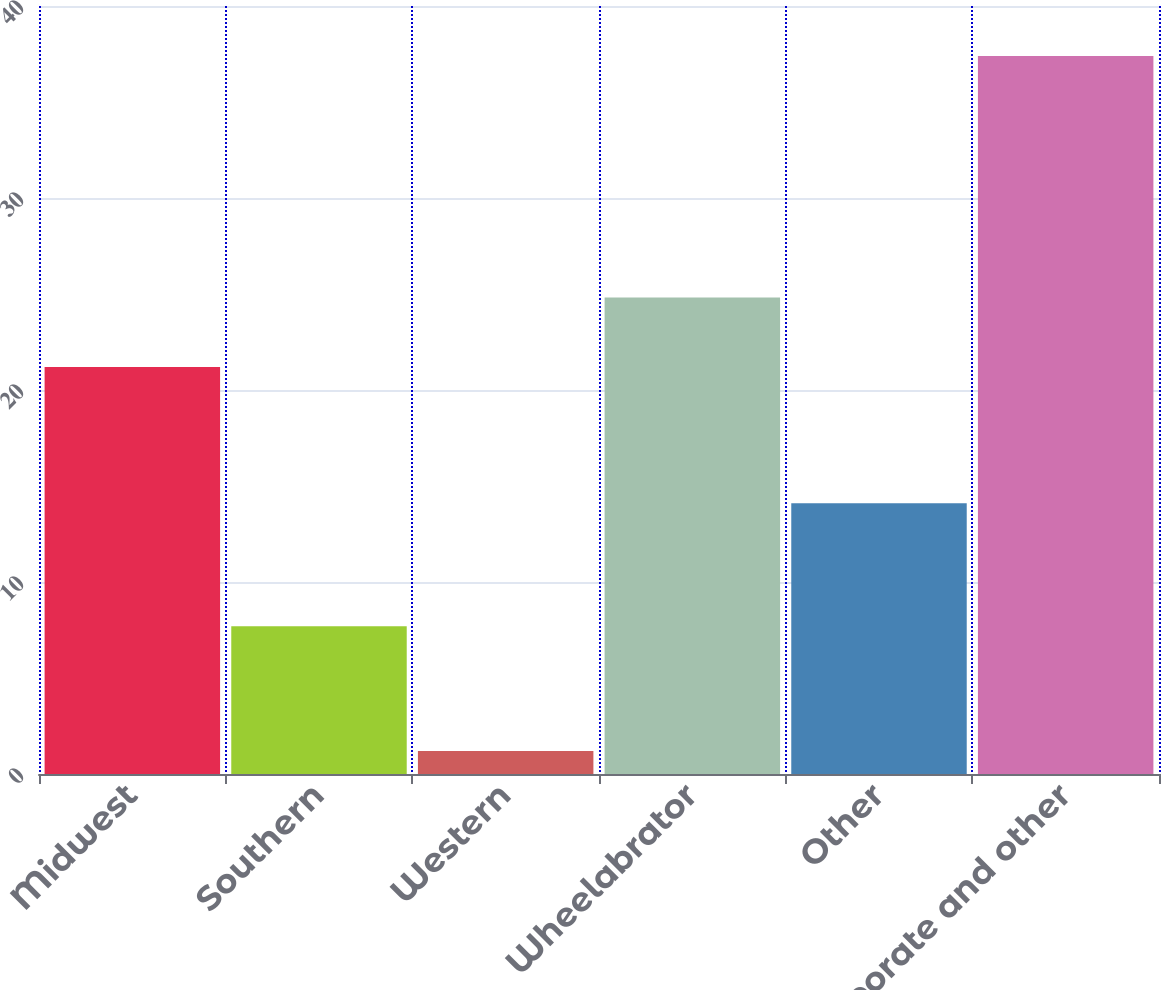Convert chart. <chart><loc_0><loc_0><loc_500><loc_500><bar_chart><fcel>Midwest<fcel>Southern<fcel>Western<fcel>Wheelabrator<fcel>Other<fcel>Corporate and other<nl><fcel>21.2<fcel>7.7<fcel>1.2<fcel>24.82<fcel>14.1<fcel>37.4<nl></chart> 